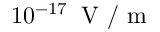Convert formula to latex. <formula><loc_0><loc_0><loc_500><loc_500>1 0 ^ { - 1 7 } \, V / m</formula> 